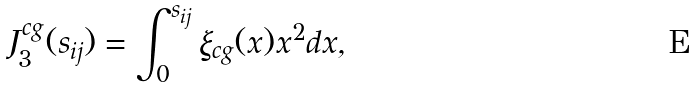<formula> <loc_0><loc_0><loc_500><loc_500>J ^ { c g } _ { 3 } ( s _ { i j } ) = \int _ { 0 } ^ { s _ { i j } } \xi _ { c g } ( x ) x ^ { 2 } d x ,</formula> 